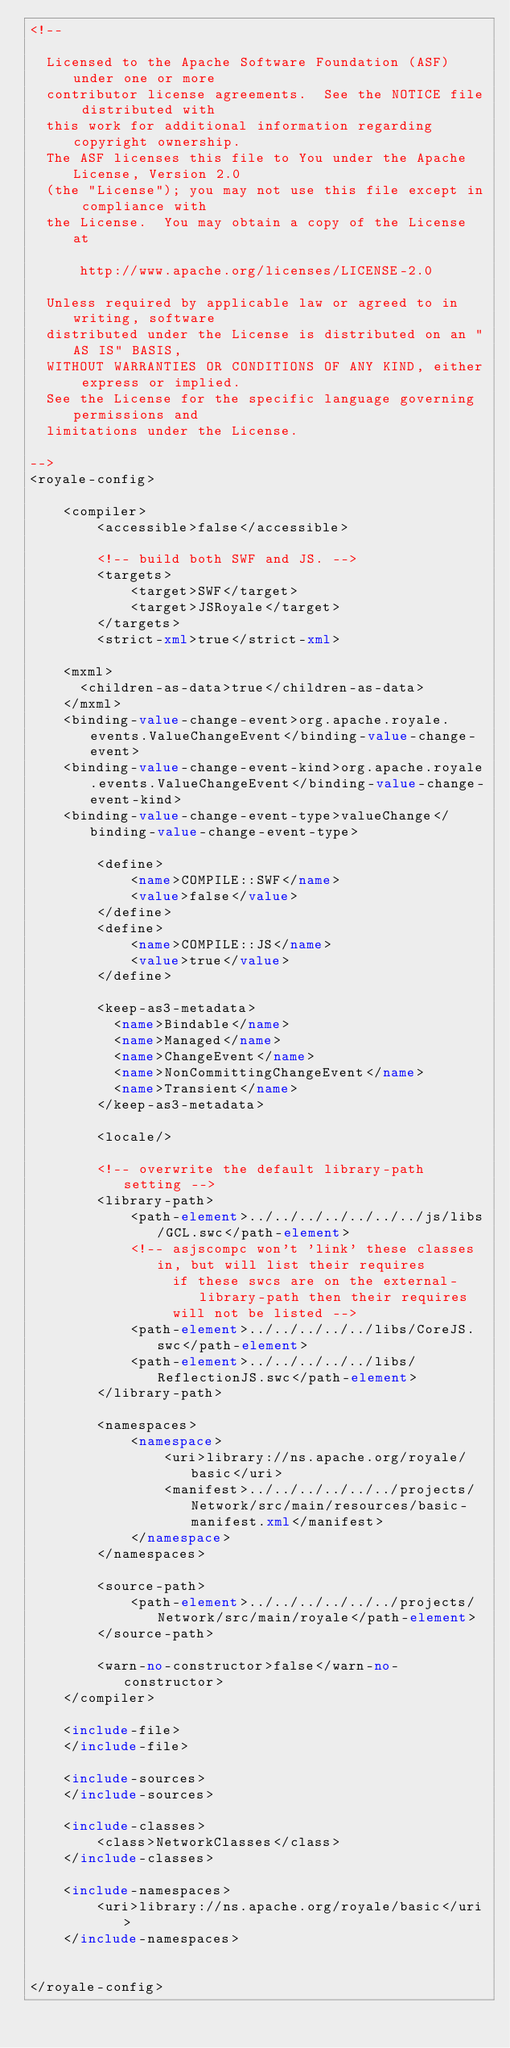<code> <loc_0><loc_0><loc_500><loc_500><_XML_><!--

  Licensed to the Apache Software Foundation (ASF) under one or more
  contributor license agreements.  See the NOTICE file distributed with
  this work for additional information regarding copyright ownership.
  The ASF licenses this file to You under the Apache License, Version 2.0
  (the "License"); you may not use this file except in compliance with
  the License.  You may obtain a copy of the License at

      http://www.apache.org/licenses/LICENSE-2.0

  Unless required by applicable law or agreed to in writing, software
  distributed under the License is distributed on an "AS IS" BASIS,
  WITHOUT WARRANTIES OR CONDITIONS OF ANY KIND, either express or implied.
  See the License for the specific language governing permissions and
  limitations under the License.

-->
<royale-config>

    <compiler>
        <accessible>false</accessible>
        
        <!-- build both SWF and JS. -->
        <targets>
            <target>SWF</target>
            <target>JSRoyale</target>
        </targets>
        <strict-xml>true</strict-xml>

		<mxml>
			<children-as-data>true</children-as-data>
		</mxml>
		<binding-value-change-event>org.apache.royale.events.ValueChangeEvent</binding-value-change-event>
		<binding-value-change-event-kind>org.apache.royale.events.ValueChangeEvent</binding-value-change-event-kind>
		<binding-value-change-event-type>valueChange</binding-value-change-event-type>

        <define>
            <name>COMPILE::SWF</name>
            <value>false</value>
        </define>
        <define>
            <name>COMPILE::JS</name>
            <value>true</value>
        </define>

        <keep-as3-metadata>
          <name>Bindable</name>
          <name>Managed</name>
          <name>ChangeEvent</name>
          <name>NonCommittingChangeEvent</name>
          <name>Transient</name>
        </keep-as3-metadata>
	  
        <locale/>
        
        <!-- overwrite the default library-path setting -->
        <library-path>
            <path-element>../../../../../../../js/libs/GCL.swc</path-element>
            <!-- asjscompc won't 'link' these classes in, but will list their requires
                 if these swcs are on the external-library-path then their requires
                 will not be listed -->
            <path-element>../../../../../libs/CoreJS.swc</path-element>
            <path-element>../../../../../libs/ReflectionJS.swc</path-element>
        </library-path>
        
        <namespaces>
            <namespace>
                <uri>library://ns.apache.org/royale/basic</uri>
                <manifest>../../../../../../projects/Network/src/main/resources/basic-manifest.xml</manifest>
            </namespace>
        </namespaces>
        
        <source-path>
            <path-element>../../../../../../projects/Network/src/main/royale</path-element>
        </source-path>
        
        <warn-no-constructor>false</warn-no-constructor>
    </compiler>
    
    <include-file>
    </include-file>

    <include-sources>
    </include-sources>
    
    <include-classes>
        <class>NetworkClasses</class>
    </include-classes>
    
    <include-namespaces>
        <uri>library://ns.apache.org/royale/basic</uri>
    </include-namespaces>
        

</royale-config>
</code> 